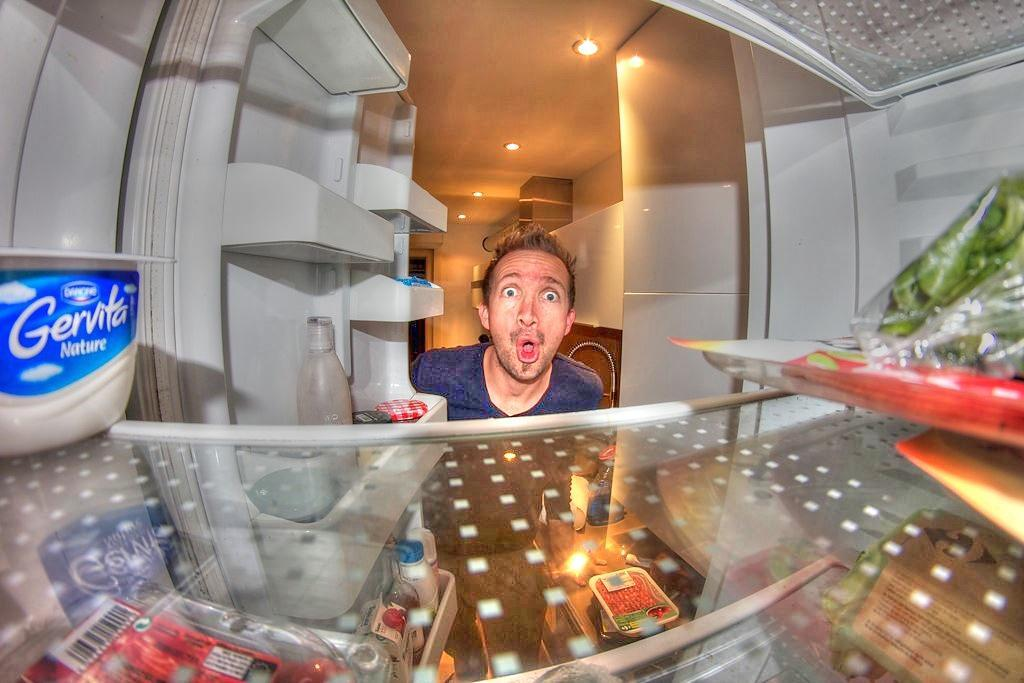What is open in the image? There is an open fridge in the image. Who or what is present in the image? There is a person in the image. What type of lighting is visible in the image? Ceiling lights are visible in the image. What is inside the fridge or on the shelves? There is a bottle and food packets present in the image. What else can be seen in the image? There are objects in the image. What type of oatmeal is being prepared in the image? There is no oatmeal present in the image, nor is there any indication of food preparation. 